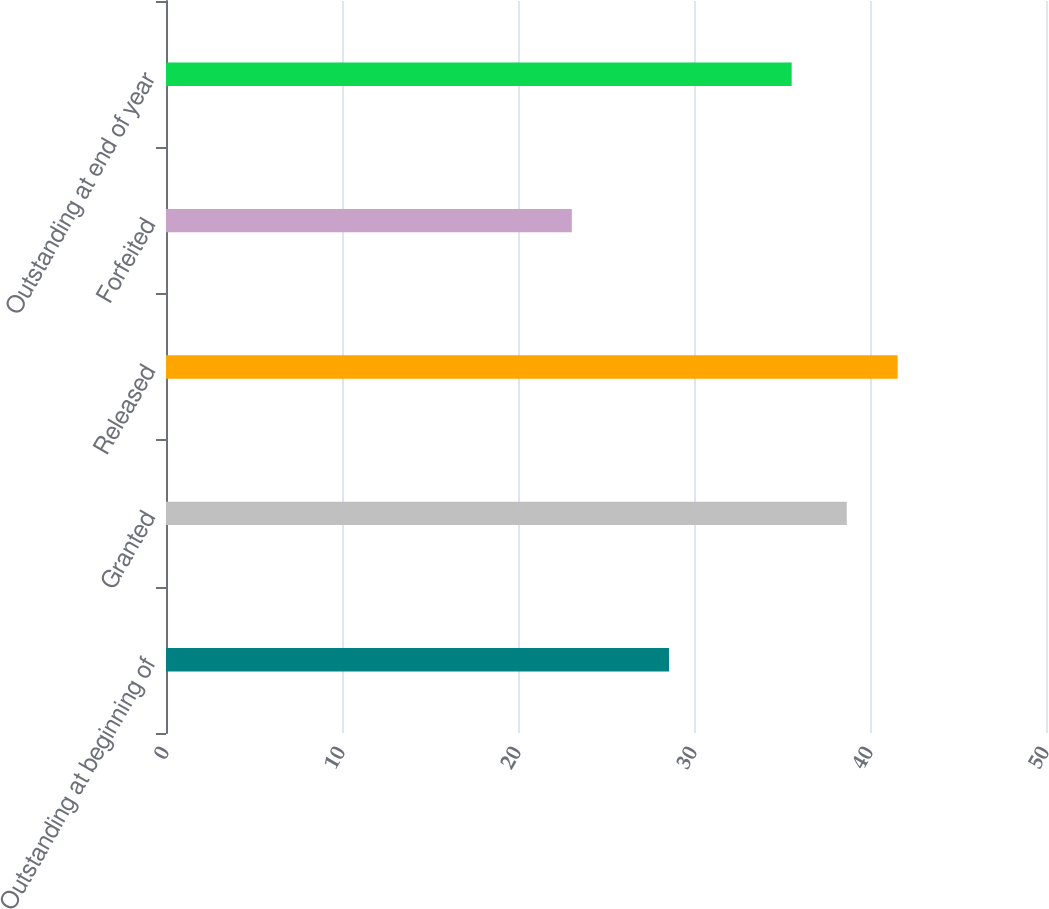<chart> <loc_0><loc_0><loc_500><loc_500><bar_chart><fcel>Outstanding at beginning of<fcel>Granted<fcel>Released<fcel>Forfeited<fcel>Outstanding at end of year<nl><fcel>28.58<fcel>38.68<fcel>41.57<fcel>23.06<fcel>35.55<nl></chart> 